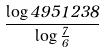Convert formula to latex. <formula><loc_0><loc_0><loc_500><loc_500>\frac { \log 4 9 5 1 2 3 8 } { \log \frac { 7 } { 6 } }</formula> 